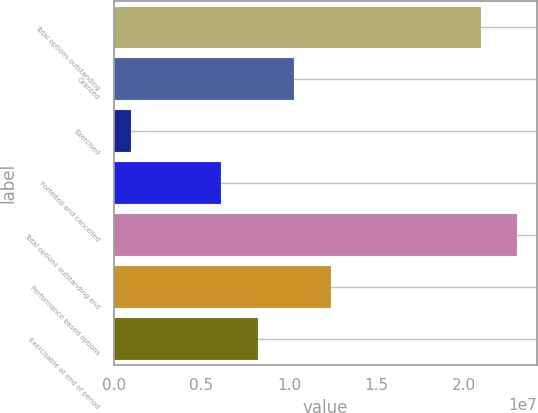<chart> <loc_0><loc_0><loc_500><loc_500><bar_chart><fcel>Total options outstanding<fcel>Granted<fcel>Exercised<fcel>Forfeited and cancelled<fcel>Total options outstanding end<fcel>Performance based options<fcel>Exercisable at end of period<nl><fcel>2.09384e+07<fcel>1.02969e+07<fcel>976187<fcel>6.12503e+06<fcel>2.30244e+07<fcel>1.23829e+07<fcel>8.21098e+06<nl></chart> 